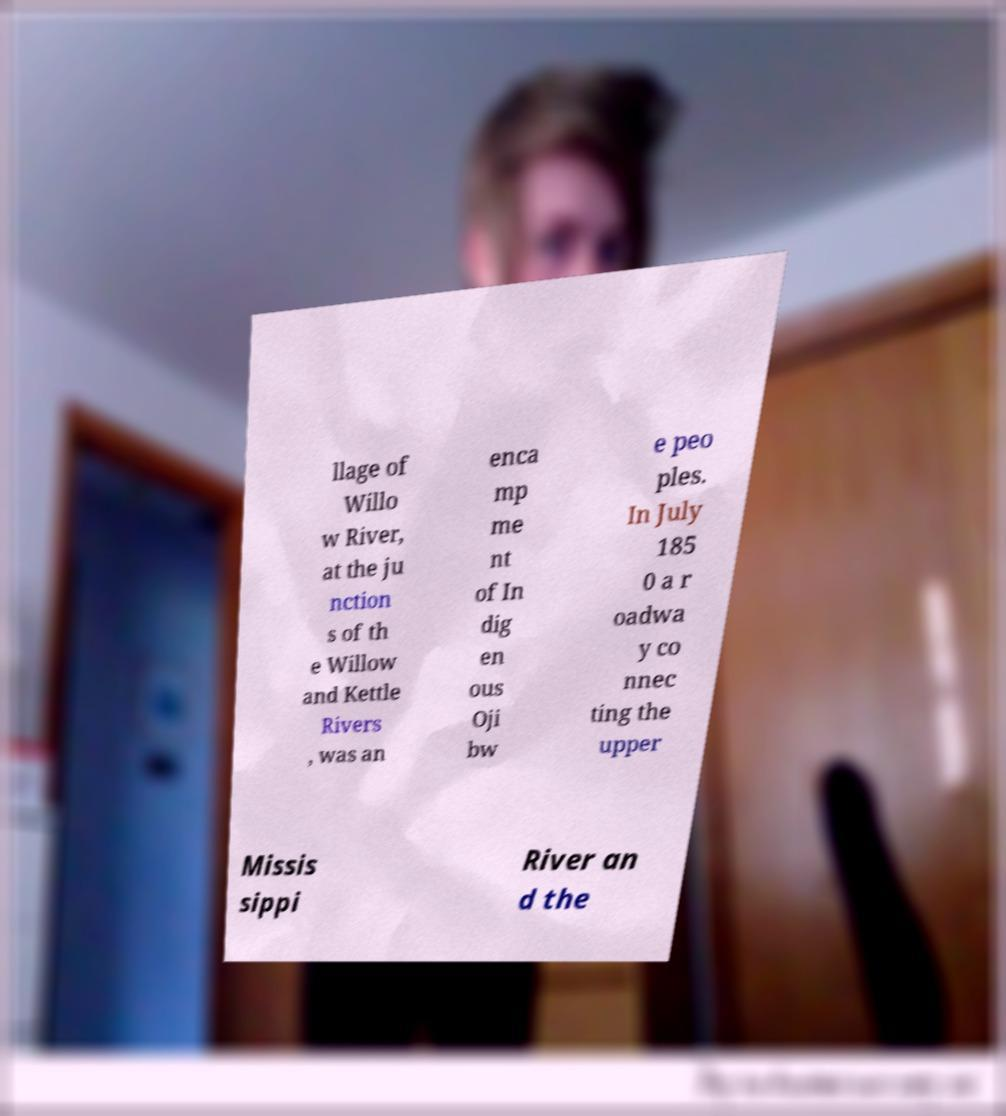Can you accurately transcribe the text from the provided image for me? llage of Willo w River, at the ju nction s of th e Willow and Kettle Rivers , was an enca mp me nt of In dig en ous Oji bw e peo ples. In July 185 0 a r oadwa y co nnec ting the upper Missis sippi River an d the 